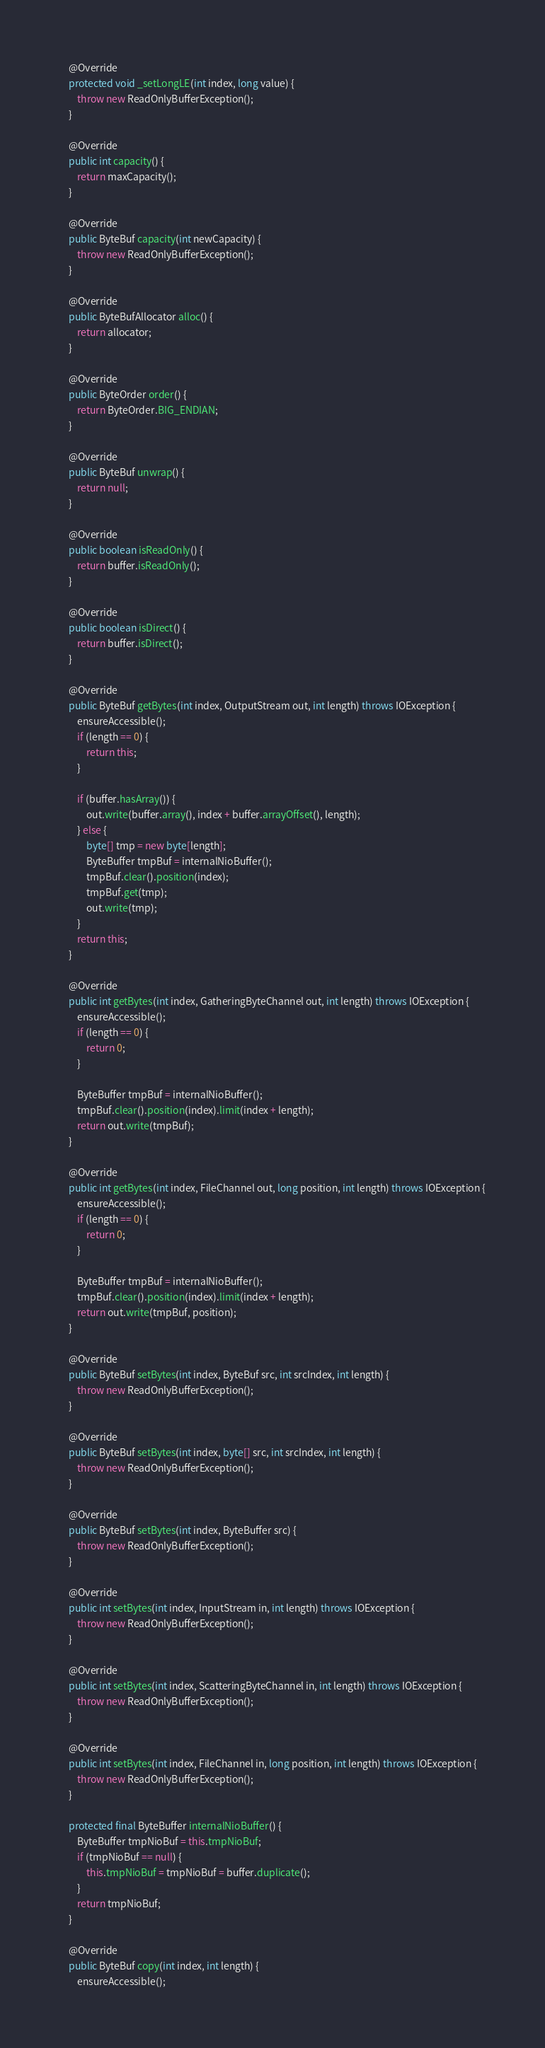<code> <loc_0><loc_0><loc_500><loc_500><_Java_>    @Override
    protected void _setLongLE(int index, long value) {
        throw new ReadOnlyBufferException();
    }

    @Override
    public int capacity() {
        return maxCapacity();
    }

    @Override
    public ByteBuf capacity(int newCapacity) {
        throw new ReadOnlyBufferException();
    }

    @Override
    public ByteBufAllocator alloc() {
        return allocator;
    }

    @Override
    public ByteOrder order() {
        return ByteOrder.BIG_ENDIAN;
    }

    @Override
    public ByteBuf unwrap() {
        return null;
    }

    @Override
    public boolean isReadOnly() {
        return buffer.isReadOnly();
    }

    @Override
    public boolean isDirect() {
        return buffer.isDirect();
    }

    @Override
    public ByteBuf getBytes(int index, OutputStream out, int length) throws IOException {
        ensureAccessible();
        if (length == 0) {
            return this;
        }

        if (buffer.hasArray()) {
            out.write(buffer.array(), index + buffer.arrayOffset(), length);
        } else {
            byte[] tmp = new byte[length];
            ByteBuffer tmpBuf = internalNioBuffer();
            tmpBuf.clear().position(index);
            tmpBuf.get(tmp);
            out.write(tmp);
        }
        return this;
    }

    @Override
    public int getBytes(int index, GatheringByteChannel out, int length) throws IOException {
        ensureAccessible();
        if (length == 0) {
            return 0;
        }

        ByteBuffer tmpBuf = internalNioBuffer();
        tmpBuf.clear().position(index).limit(index + length);
        return out.write(tmpBuf);
    }

    @Override
    public int getBytes(int index, FileChannel out, long position, int length) throws IOException {
        ensureAccessible();
        if (length == 0) {
            return 0;
        }

        ByteBuffer tmpBuf = internalNioBuffer();
        tmpBuf.clear().position(index).limit(index + length);
        return out.write(tmpBuf, position);
    }

    @Override
    public ByteBuf setBytes(int index, ByteBuf src, int srcIndex, int length) {
        throw new ReadOnlyBufferException();
    }

    @Override
    public ByteBuf setBytes(int index, byte[] src, int srcIndex, int length) {
        throw new ReadOnlyBufferException();
    }

    @Override
    public ByteBuf setBytes(int index, ByteBuffer src) {
        throw new ReadOnlyBufferException();
    }

    @Override
    public int setBytes(int index, InputStream in, int length) throws IOException {
        throw new ReadOnlyBufferException();
    }

    @Override
    public int setBytes(int index, ScatteringByteChannel in, int length) throws IOException {
        throw new ReadOnlyBufferException();
    }

    @Override
    public int setBytes(int index, FileChannel in, long position, int length) throws IOException {
        throw new ReadOnlyBufferException();
    }

    protected final ByteBuffer internalNioBuffer() {
        ByteBuffer tmpNioBuf = this.tmpNioBuf;
        if (tmpNioBuf == null) {
            this.tmpNioBuf = tmpNioBuf = buffer.duplicate();
        }
        return tmpNioBuf;
    }

    @Override
    public ByteBuf copy(int index, int length) {
        ensureAccessible();</code> 